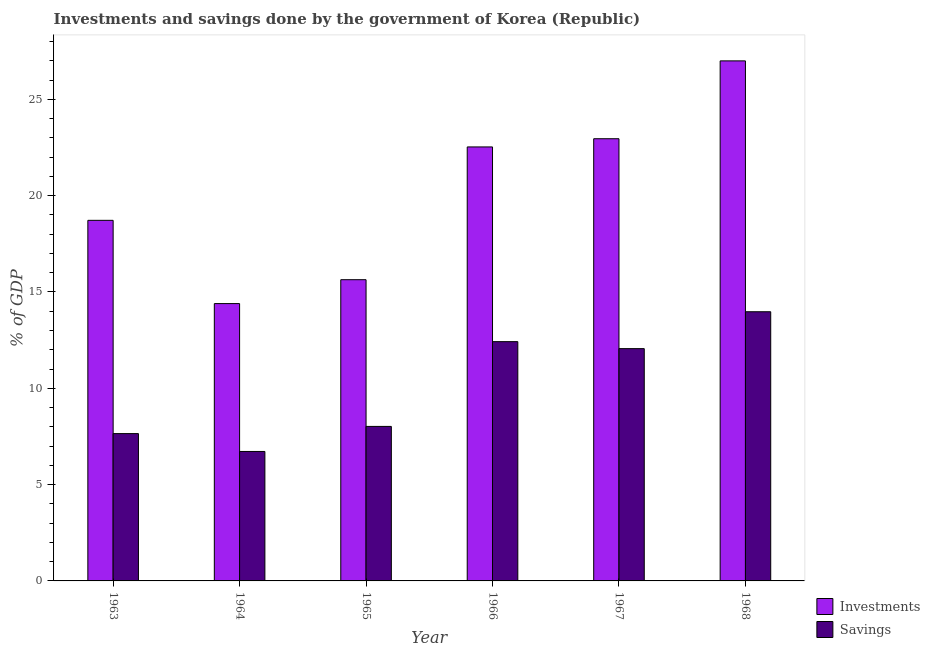How many different coloured bars are there?
Offer a terse response. 2. Are the number of bars per tick equal to the number of legend labels?
Offer a very short reply. Yes. Are the number of bars on each tick of the X-axis equal?
Ensure brevity in your answer.  Yes. How many bars are there on the 2nd tick from the left?
Provide a succinct answer. 2. How many bars are there on the 3rd tick from the right?
Give a very brief answer. 2. What is the label of the 6th group of bars from the left?
Your answer should be very brief. 1968. What is the savings of government in 1967?
Offer a terse response. 12.06. Across all years, what is the maximum savings of government?
Your answer should be very brief. 13.97. Across all years, what is the minimum savings of government?
Provide a short and direct response. 6.72. In which year was the investments of government maximum?
Your answer should be very brief. 1968. In which year was the savings of government minimum?
Provide a short and direct response. 1964. What is the total investments of government in the graph?
Give a very brief answer. 121.23. What is the difference between the investments of government in 1966 and that in 1967?
Make the answer very short. -0.43. What is the difference between the savings of government in 1963 and the investments of government in 1967?
Offer a terse response. -4.41. What is the average savings of government per year?
Keep it short and to the point. 10.14. In the year 1964, what is the difference between the investments of government and savings of government?
Your answer should be compact. 0. In how many years, is the savings of government greater than 23 %?
Your answer should be very brief. 0. What is the ratio of the savings of government in 1965 to that in 1967?
Your answer should be very brief. 0.67. What is the difference between the highest and the second highest savings of government?
Give a very brief answer. 1.55. What is the difference between the highest and the lowest investments of government?
Keep it short and to the point. 12.6. What does the 1st bar from the left in 1963 represents?
Your response must be concise. Investments. What does the 1st bar from the right in 1966 represents?
Make the answer very short. Savings. Does the graph contain grids?
Your answer should be very brief. No. Where does the legend appear in the graph?
Make the answer very short. Bottom right. What is the title of the graph?
Keep it short and to the point. Investments and savings done by the government of Korea (Republic). Does "Measles" appear as one of the legend labels in the graph?
Your answer should be very brief. No. What is the label or title of the Y-axis?
Provide a short and direct response. % of GDP. What is the % of GDP in Investments in 1963?
Your answer should be very brief. 18.72. What is the % of GDP of Savings in 1963?
Keep it short and to the point. 7.65. What is the % of GDP in Investments in 1964?
Keep it short and to the point. 14.4. What is the % of GDP of Savings in 1964?
Keep it short and to the point. 6.72. What is the % of GDP of Investments in 1965?
Your response must be concise. 15.64. What is the % of GDP of Savings in 1965?
Give a very brief answer. 8.02. What is the % of GDP of Investments in 1966?
Make the answer very short. 22.53. What is the % of GDP of Savings in 1966?
Your answer should be very brief. 12.42. What is the % of GDP of Investments in 1967?
Ensure brevity in your answer.  22.95. What is the % of GDP of Savings in 1967?
Offer a terse response. 12.06. What is the % of GDP of Investments in 1968?
Ensure brevity in your answer.  26.99. What is the % of GDP in Savings in 1968?
Give a very brief answer. 13.97. Across all years, what is the maximum % of GDP in Investments?
Provide a succinct answer. 26.99. Across all years, what is the maximum % of GDP in Savings?
Give a very brief answer. 13.97. Across all years, what is the minimum % of GDP in Investments?
Make the answer very short. 14.4. Across all years, what is the minimum % of GDP in Savings?
Ensure brevity in your answer.  6.72. What is the total % of GDP of Investments in the graph?
Provide a short and direct response. 121.23. What is the total % of GDP in Savings in the graph?
Your answer should be compact. 60.84. What is the difference between the % of GDP of Investments in 1963 and that in 1964?
Ensure brevity in your answer.  4.32. What is the difference between the % of GDP in Savings in 1963 and that in 1964?
Your response must be concise. 0.93. What is the difference between the % of GDP in Investments in 1963 and that in 1965?
Your response must be concise. 3.08. What is the difference between the % of GDP in Savings in 1963 and that in 1965?
Provide a short and direct response. -0.37. What is the difference between the % of GDP of Investments in 1963 and that in 1966?
Your response must be concise. -3.81. What is the difference between the % of GDP of Savings in 1963 and that in 1966?
Your answer should be compact. -4.77. What is the difference between the % of GDP of Investments in 1963 and that in 1967?
Ensure brevity in your answer.  -4.24. What is the difference between the % of GDP of Savings in 1963 and that in 1967?
Provide a short and direct response. -4.41. What is the difference between the % of GDP of Investments in 1963 and that in 1968?
Ensure brevity in your answer.  -8.28. What is the difference between the % of GDP in Savings in 1963 and that in 1968?
Make the answer very short. -6.33. What is the difference between the % of GDP of Investments in 1964 and that in 1965?
Provide a short and direct response. -1.24. What is the difference between the % of GDP of Savings in 1964 and that in 1965?
Your answer should be very brief. -1.3. What is the difference between the % of GDP in Investments in 1964 and that in 1966?
Provide a succinct answer. -8.13. What is the difference between the % of GDP of Savings in 1964 and that in 1966?
Your answer should be compact. -5.7. What is the difference between the % of GDP in Investments in 1964 and that in 1967?
Provide a short and direct response. -8.56. What is the difference between the % of GDP in Savings in 1964 and that in 1967?
Provide a succinct answer. -5.34. What is the difference between the % of GDP of Investments in 1964 and that in 1968?
Make the answer very short. -12.6. What is the difference between the % of GDP in Savings in 1964 and that in 1968?
Give a very brief answer. -7.25. What is the difference between the % of GDP in Investments in 1965 and that in 1966?
Offer a terse response. -6.89. What is the difference between the % of GDP of Savings in 1965 and that in 1966?
Keep it short and to the point. -4.4. What is the difference between the % of GDP of Investments in 1965 and that in 1967?
Provide a short and direct response. -7.32. What is the difference between the % of GDP in Savings in 1965 and that in 1967?
Your answer should be very brief. -4.04. What is the difference between the % of GDP in Investments in 1965 and that in 1968?
Give a very brief answer. -11.36. What is the difference between the % of GDP in Savings in 1965 and that in 1968?
Your answer should be compact. -5.95. What is the difference between the % of GDP in Investments in 1966 and that in 1967?
Provide a succinct answer. -0.43. What is the difference between the % of GDP in Savings in 1966 and that in 1967?
Ensure brevity in your answer.  0.36. What is the difference between the % of GDP of Investments in 1966 and that in 1968?
Your answer should be compact. -4.47. What is the difference between the % of GDP in Savings in 1966 and that in 1968?
Offer a very short reply. -1.55. What is the difference between the % of GDP of Investments in 1967 and that in 1968?
Ensure brevity in your answer.  -4.04. What is the difference between the % of GDP of Savings in 1967 and that in 1968?
Provide a succinct answer. -1.91. What is the difference between the % of GDP in Investments in 1963 and the % of GDP in Savings in 1964?
Provide a short and direct response. 12. What is the difference between the % of GDP of Investments in 1963 and the % of GDP of Savings in 1965?
Your answer should be very brief. 10.7. What is the difference between the % of GDP in Investments in 1963 and the % of GDP in Savings in 1966?
Your response must be concise. 6.3. What is the difference between the % of GDP of Investments in 1963 and the % of GDP of Savings in 1967?
Your answer should be compact. 6.66. What is the difference between the % of GDP of Investments in 1963 and the % of GDP of Savings in 1968?
Your answer should be very brief. 4.75. What is the difference between the % of GDP in Investments in 1964 and the % of GDP in Savings in 1965?
Make the answer very short. 6.38. What is the difference between the % of GDP of Investments in 1964 and the % of GDP of Savings in 1966?
Provide a succinct answer. 1.98. What is the difference between the % of GDP in Investments in 1964 and the % of GDP in Savings in 1967?
Provide a succinct answer. 2.34. What is the difference between the % of GDP of Investments in 1964 and the % of GDP of Savings in 1968?
Give a very brief answer. 0.42. What is the difference between the % of GDP of Investments in 1965 and the % of GDP of Savings in 1966?
Provide a short and direct response. 3.22. What is the difference between the % of GDP of Investments in 1965 and the % of GDP of Savings in 1967?
Provide a succinct answer. 3.58. What is the difference between the % of GDP in Investments in 1965 and the % of GDP in Savings in 1968?
Provide a succinct answer. 1.66. What is the difference between the % of GDP in Investments in 1966 and the % of GDP in Savings in 1967?
Ensure brevity in your answer.  10.47. What is the difference between the % of GDP of Investments in 1966 and the % of GDP of Savings in 1968?
Ensure brevity in your answer.  8.56. What is the difference between the % of GDP in Investments in 1967 and the % of GDP in Savings in 1968?
Make the answer very short. 8.98. What is the average % of GDP in Investments per year?
Offer a terse response. 20.2. What is the average % of GDP of Savings per year?
Your answer should be compact. 10.14. In the year 1963, what is the difference between the % of GDP of Investments and % of GDP of Savings?
Your response must be concise. 11.07. In the year 1964, what is the difference between the % of GDP in Investments and % of GDP in Savings?
Provide a short and direct response. 7.68. In the year 1965, what is the difference between the % of GDP of Investments and % of GDP of Savings?
Ensure brevity in your answer.  7.62. In the year 1966, what is the difference between the % of GDP in Investments and % of GDP in Savings?
Offer a terse response. 10.11. In the year 1967, what is the difference between the % of GDP of Investments and % of GDP of Savings?
Offer a very short reply. 10.9. In the year 1968, what is the difference between the % of GDP in Investments and % of GDP in Savings?
Provide a short and direct response. 13.02. What is the ratio of the % of GDP of Investments in 1963 to that in 1964?
Provide a succinct answer. 1.3. What is the ratio of the % of GDP of Savings in 1963 to that in 1964?
Your response must be concise. 1.14. What is the ratio of the % of GDP of Investments in 1963 to that in 1965?
Offer a very short reply. 1.2. What is the ratio of the % of GDP of Savings in 1963 to that in 1965?
Ensure brevity in your answer.  0.95. What is the ratio of the % of GDP in Investments in 1963 to that in 1966?
Offer a very short reply. 0.83. What is the ratio of the % of GDP in Savings in 1963 to that in 1966?
Your answer should be compact. 0.62. What is the ratio of the % of GDP of Investments in 1963 to that in 1967?
Offer a very short reply. 0.82. What is the ratio of the % of GDP of Savings in 1963 to that in 1967?
Offer a very short reply. 0.63. What is the ratio of the % of GDP of Investments in 1963 to that in 1968?
Offer a terse response. 0.69. What is the ratio of the % of GDP in Savings in 1963 to that in 1968?
Provide a short and direct response. 0.55. What is the ratio of the % of GDP in Investments in 1964 to that in 1965?
Give a very brief answer. 0.92. What is the ratio of the % of GDP of Savings in 1964 to that in 1965?
Provide a short and direct response. 0.84. What is the ratio of the % of GDP in Investments in 1964 to that in 1966?
Keep it short and to the point. 0.64. What is the ratio of the % of GDP of Savings in 1964 to that in 1966?
Provide a succinct answer. 0.54. What is the ratio of the % of GDP of Investments in 1964 to that in 1967?
Provide a short and direct response. 0.63. What is the ratio of the % of GDP in Savings in 1964 to that in 1967?
Your answer should be compact. 0.56. What is the ratio of the % of GDP in Investments in 1964 to that in 1968?
Give a very brief answer. 0.53. What is the ratio of the % of GDP of Savings in 1964 to that in 1968?
Your response must be concise. 0.48. What is the ratio of the % of GDP in Investments in 1965 to that in 1966?
Your response must be concise. 0.69. What is the ratio of the % of GDP in Savings in 1965 to that in 1966?
Keep it short and to the point. 0.65. What is the ratio of the % of GDP in Investments in 1965 to that in 1967?
Your response must be concise. 0.68. What is the ratio of the % of GDP of Savings in 1965 to that in 1967?
Ensure brevity in your answer.  0.67. What is the ratio of the % of GDP of Investments in 1965 to that in 1968?
Make the answer very short. 0.58. What is the ratio of the % of GDP of Savings in 1965 to that in 1968?
Make the answer very short. 0.57. What is the ratio of the % of GDP in Investments in 1966 to that in 1967?
Make the answer very short. 0.98. What is the ratio of the % of GDP in Investments in 1966 to that in 1968?
Provide a succinct answer. 0.83. What is the ratio of the % of GDP of Investments in 1967 to that in 1968?
Offer a very short reply. 0.85. What is the ratio of the % of GDP in Savings in 1967 to that in 1968?
Offer a terse response. 0.86. What is the difference between the highest and the second highest % of GDP of Investments?
Your response must be concise. 4.04. What is the difference between the highest and the second highest % of GDP of Savings?
Make the answer very short. 1.55. What is the difference between the highest and the lowest % of GDP in Investments?
Your answer should be compact. 12.6. What is the difference between the highest and the lowest % of GDP in Savings?
Offer a terse response. 7.25. 